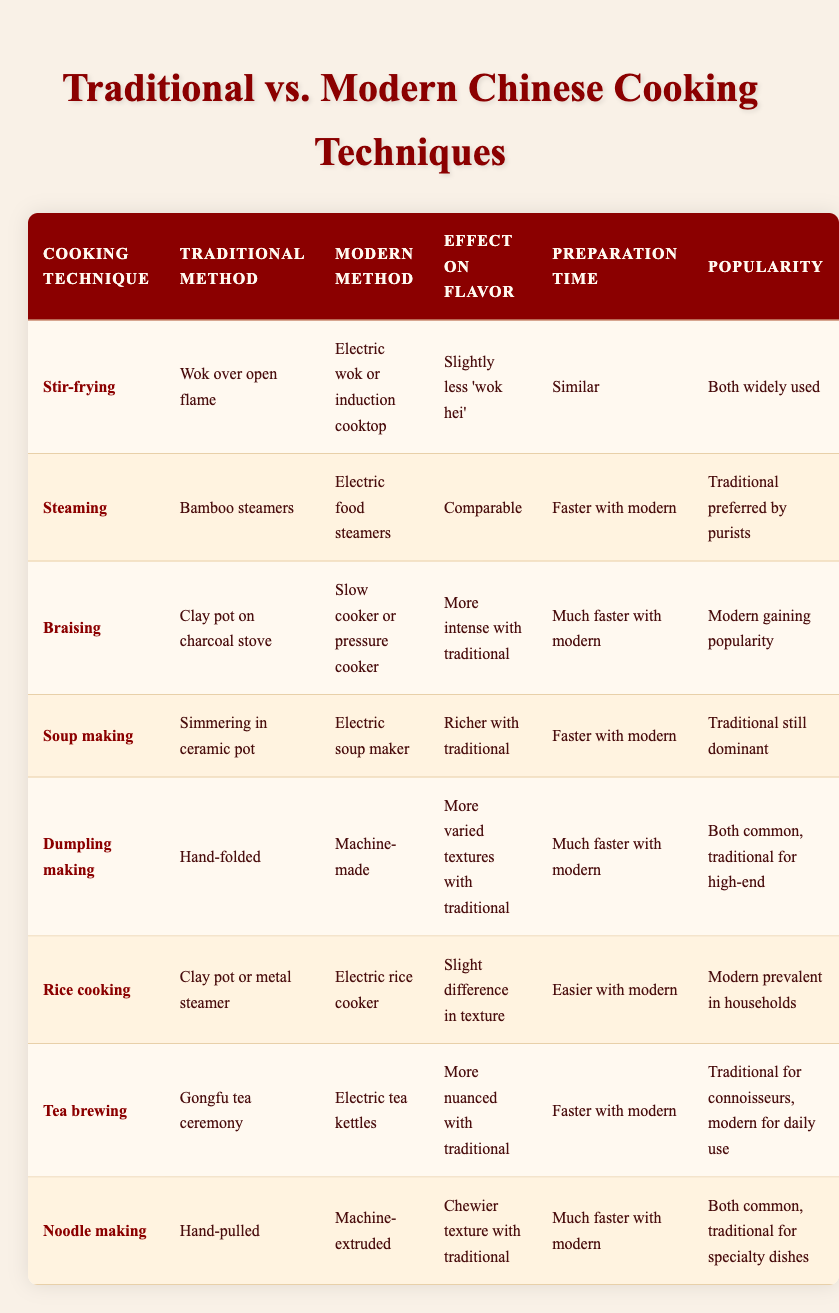What is the traditional method for making dumplings? The traditional method for making dumplings is hand-folded as stated in the table under the "Traditional Method" column for "Dumpling making."
Answer: Hand-folded Which cooking technique shows a faster preparation time with modern methods? The table indicates that steaming shows a faster preparation time with modern methods compared to traditional methods, specifically in the "Preparation Time" column for "Steaming."
Answer: Steaming Is it true that traditional braising has a more intense flavor than modern braising? According to the table, it states that traditional braising, which uses clay pots on charcoal stoves, results in a more intense flavor compared to modern methods, validating the statement as true.
Answer: Yes What cooking techniques are both considered popular in Chinese cuisine? The table shows that both stir-frying and dumpling making are widely used, based on the "Popularity" column. Therefore, both techniques are considered popular.
Answer: Stir-frying, Dumpling making Which cooking technique has a significant difference in flavor between traditional and modern methods? The table highlights that braising has a more intense flavor with the traditional method compared to the modern method, indicating a significant difference in flavor.
Answer: Braising How many cooking techniques use a modern method that is classified as faster? By examining the table, we find that three cooking techniques—steaming, soup making, and braising—are noted as faster with modern methods. Summing these gives a total of three techniques.
Answer: 3 For which cooking techniques does the modern method dominate in popularity? The table states that modern methods are prevalent for rice cooking and are gaining popularity in braising. Thus, these techniques show modern methods dominating in popularity.
Answer: Rice cooking, Braising Is the texture difference between traditional and modern rice cooking techniques significant? The table notes a slight difference in texture when comparing traditional and modern methods of rice cooking, suggesting that the difference is not significant.
Answer: No Which cooking technique is most preferred by purists? According to the table, steaming is preferred by purists as highlighted in the "Popularity" column, differentiating it from modern methods.
Answer: Steaming 